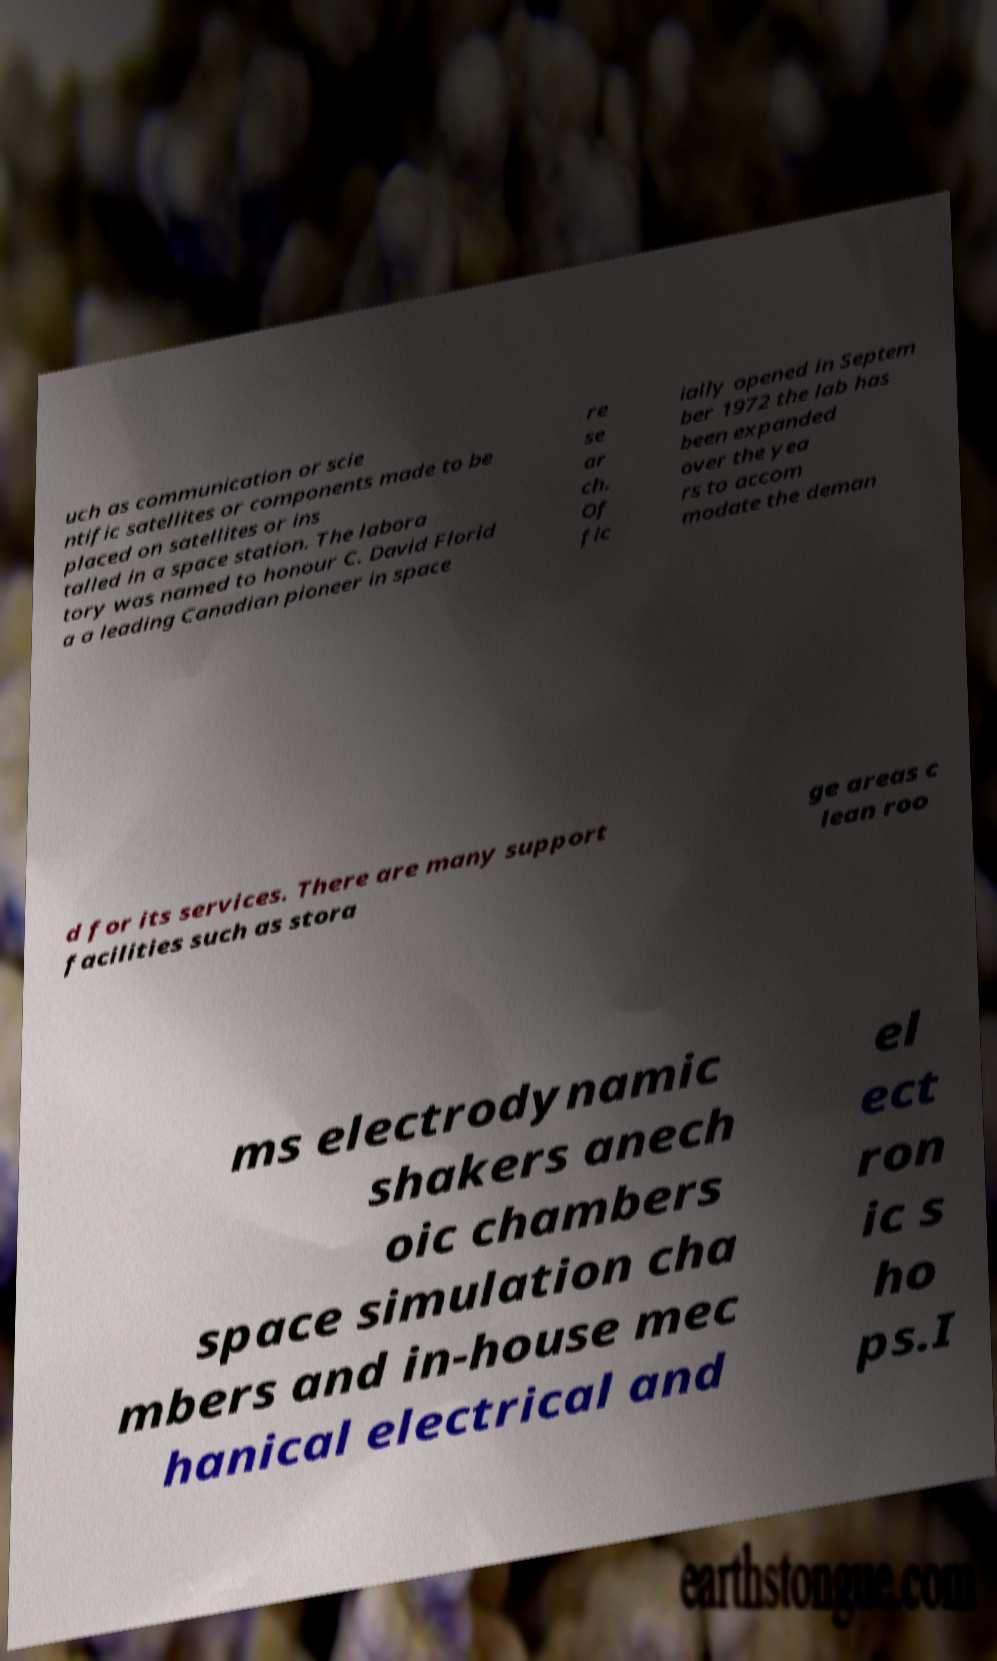Can you accurately transcribe the text from the provided image for me? uch as communication or scie ntific satellites or components made to be placed on satellites or ins talled in a space station. The labora tory was named to honour C. David Florid a a leading Canadian pioneer in space re se ar ch. Of fic ially opened in Septem ber 1972 the lab has been expanded over the yea rs to accom modate the deman d for its services. There are many support facilities such as stora ge areas c lean roo ms electrodynamic shakers anech oic chambers space simulation cha mbers and in-house mec hanical electrical and el ect ron ic s ho ps.I 